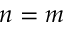<formula> <loc_0><loc_0><loc_500><loc_500>n = m</formula> 